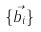<formula> <loc_0><loc_0><loc_500><loc_500>\{ \vec { b _ { i } } \}</formula> 